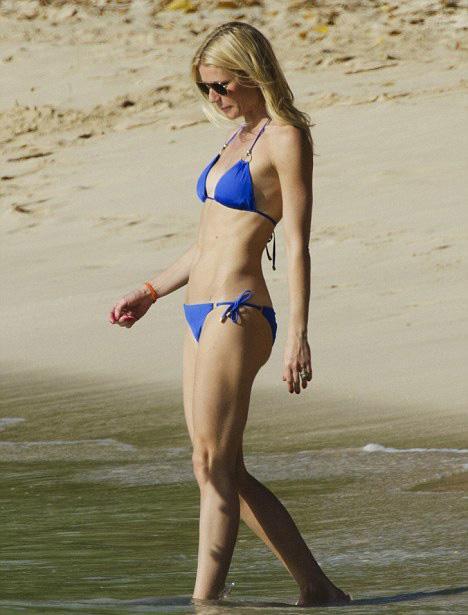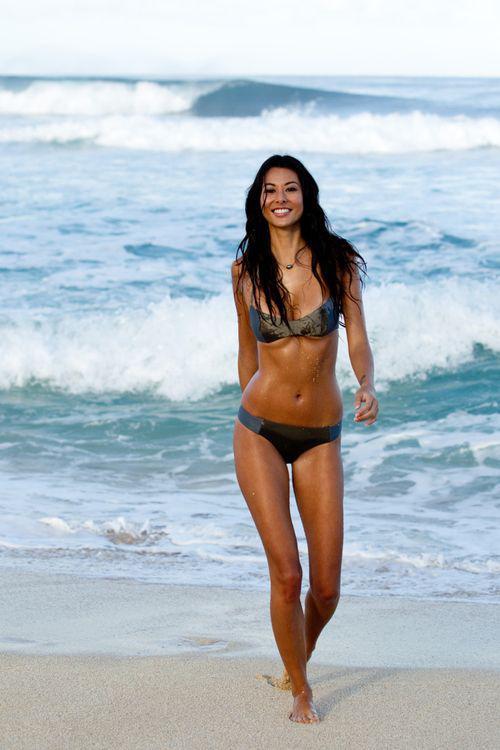The first image is the image on the left, the second image is the image on the right. Evaluate the accuracy of this statement regarding the images: "The female on the right image has her hair tied up.". Is it true? Answer yes or no. No. The first image is the image on the left, the second image is the image on the right. For the images displayed, is the sentence "One woman is standing in the water." factually correct? Answer yes or no. Yes. 